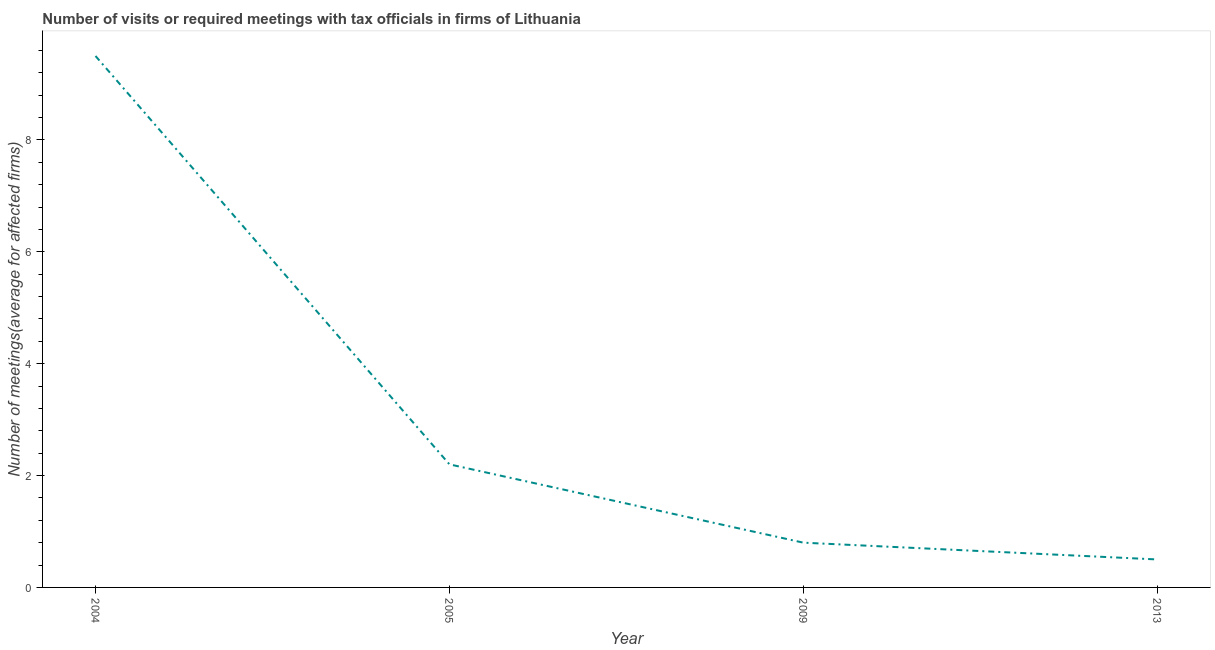What is the number of required meetings with tax officials in 2013?
Keep it short and to the point. 0.5. Across all years, what is the maximum number of required meetings with tax officials?
Provide a short and direct response. 9.5. Across all years, what is the minimum number of required meetings with tax officials?
Provide a succinct answer. 0.5. In which year was the number of required meetings with tax officials minimum?
Offer a very short reply. 2013. What is the median number of required meetings with tax officials?
Give a very brief answer. 1.5. What is the ratio of the number of required meetings with tax officials in 2004 to that in 2005?
Offer a terse response. 4.32. Is the difference between the number of required meetings with tax officials in 2005 and 2009 greater than the difference between any two years?
Your response must be concise. No. What is the difference between the highest and the second highest number of required meetings with tax officials?
Offer a very short reply. 7.3. Is the sum of the number of required meetings with tax officials in 2004 and 2009 greater than the maximum number of required meetings with tax officials across all years?
Your answer should be very brief. Yes. What is the difference between the highest and the lowest number of required meetings with tax officials?
Provide a short and direct response. 9. Does the number of required meetings with tax officials monotonically increase over the years?
Your answer should be very brief. No. What is the difference between two consecutive major ticks on the Y-axis?
Provide a succinct answer. 2. Are the values on the major ticks of Y-axis written in scientific E-notation?
Your answer should be compact. No. What is the title of the graph?
Ensure brevity in your answer.  Number of visits or required meetings with tax officials in firms of Lithuania. What is the label or title of the Y-axis?
Keep it short and to the point. Number of meetings(average for affected firms). What is the Number of meetings(average for affected firms) of 2004?
Your answer should be compact. 9.5. What is the Number of meetings(average for affected firms) in 2005?
Offer a very short reply. 2.2. What is the Number of meetings(average for affected firms) in 2013?
Give a very brief answer. 0.5. What is the difference between the Number of meetings(average for affected firms) in 2004 and 2005?
Offer a very short reply. 7.3. What is the difference between the Number of meetings(average for affected firms) in 2004 and 2009?
Provide a short and direct response. 8.7. What is the difference between the Number of meetings(average for affected firms) in 2004 and 2013?
Provide a short and direct response. 9. What is the difference between the Number of meetings(average for affected firms) in 2009 and 2013?
Offer a terse response. 0.3. What is the ratio of the Number of meetings(average for affected firms) in 2004 to that in 2005?
Provide a succinct answer. 4.32. What is the ratio of the Number of meetings(average for affected firms) in 2004 to that in 2009?
Give a very brief answer. 11.88. What is the ratio of the Number of meetings(average for affected firms) in 2005 to that in 2009?
Keep it short and to the point. 2.75. What is the ratio of the Number of meetings(average for affected firms) in 2005 to that in 2013?
Offer a very short reply. 4.4. What is the ratio of the Number of meetings(average for affected firms) in 2009 to that in 2013?
Give a very brief answer. 1.6. 